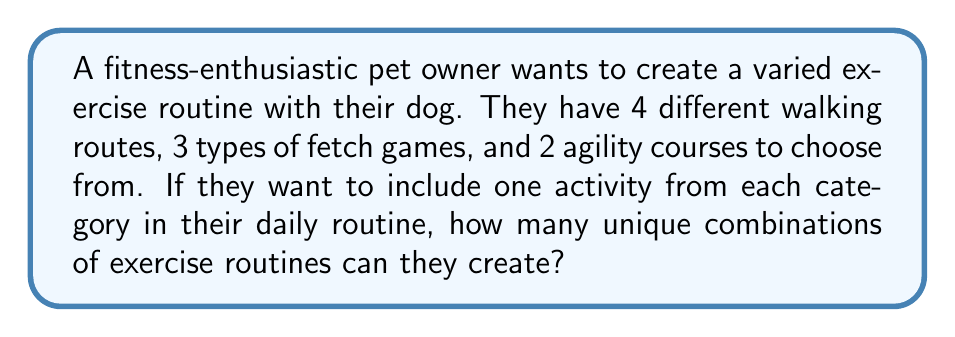Provide a solution to this math problem. Let's approach this step-by-step using the multiplication principle of counting:

1) We have three categories of activities:
   - Walking routes: 4 options
   - Fetch games: 3 options
   - Agility courses: 2 options

2) For each daily routine, the pet owner chooses:
   - One walking route out of 4
   - One fetch game out of 3
   - One agility course out of 2

3) According to the multiplication principle, when we have a sequence of independent choices, we multiply the number of options for each choice:

   $$\text{Total combinations} = \text{Walking options} \times \text{Fetch options} \times \text{Agility options}$$

4) Substituting the values:

   $$\text{Total combinations} = 4 \times 3 \times 2$$

5) Calculating:

   $$\text{Total combinations} = 24$$

Therefore, the pet owner can create 24 unique combinations of exercise routines with their dog.
Answer: 24 